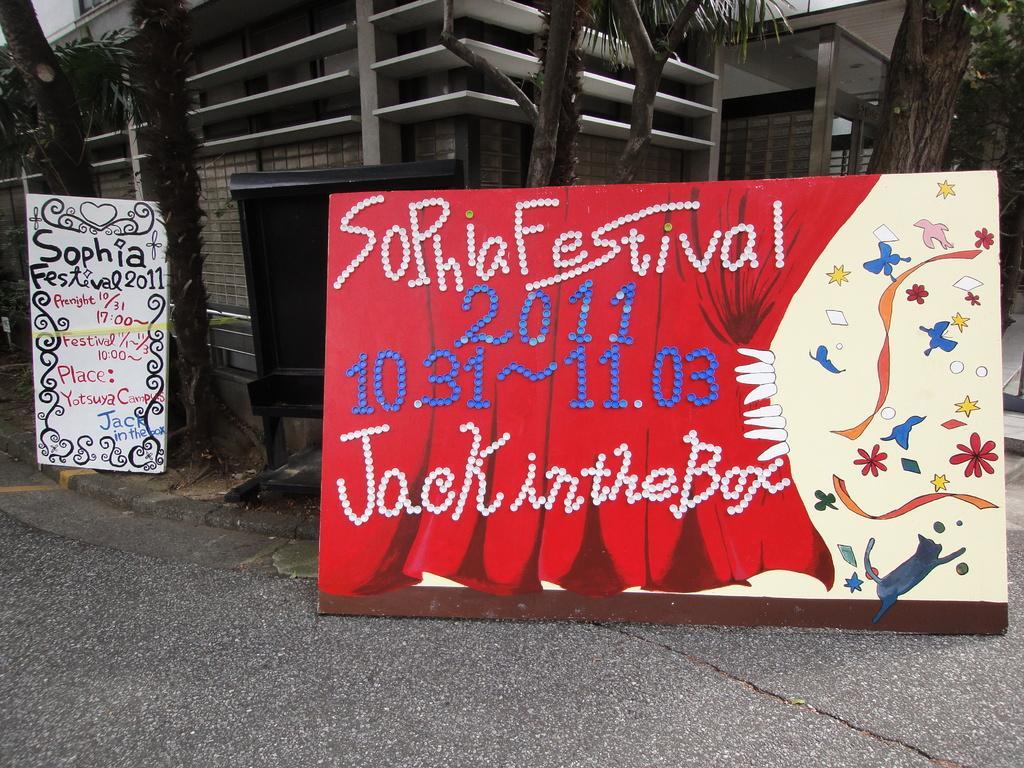Could you give a brief overview of what you see in this image? In this image, we can see a building and some boards with text and images. We can see some trees and a metal object. We can also see the ground. 